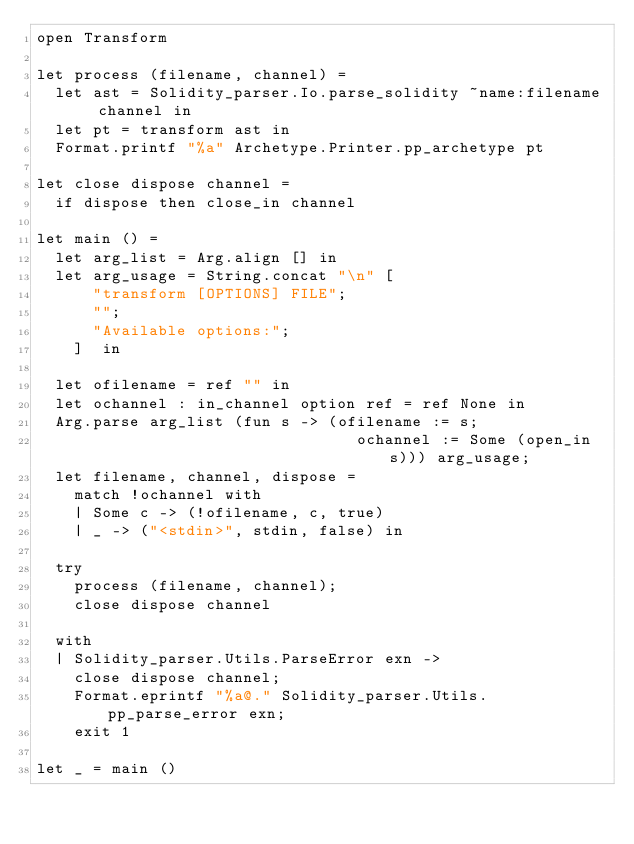<code> <loc_0><loc_0><loc_500><loc_500><_OCaml_>open Transform

let process (filename, channel) =
  let ast = Solidity_parser.Io.parse_solidity ~name:filename channel in
  let pt = transform ast in
  Format.printf "%a" Archetype.Printer.pp_archetype pt

let close dispose channel =
  if dispose then close_in channel

let main () =
  let arg_list = Arg.align [] in
  let arg_usage = String.concat "\n" [
      "transform [OPTIONS] FILE";
      "";
      "Available options:";
    ]  in

  let ofilename = ref "" in
  let ochannel : in_channel option ref = ref None in
  Arg.parse arg_list (fun s -> (ofilename := s;
                                  ochannel := Some (open_in s))) arg_usage;
  let filename, channel, dispose =
    match !ochannel with
    | Some c -> (!ofilename, c, true)
    | _ -> ("<stdin>", stdin, false) in

  try
    process (filename, channel);
    close dispose channel

  with
  | Solidity_parser.Utils.ParseError exn ->
    close dispose channel;
    Format.eprintf "%a@." Solidity_parser.Utils.pp_parse_error exn;
    exit 1

let _ = main ()
</code> 